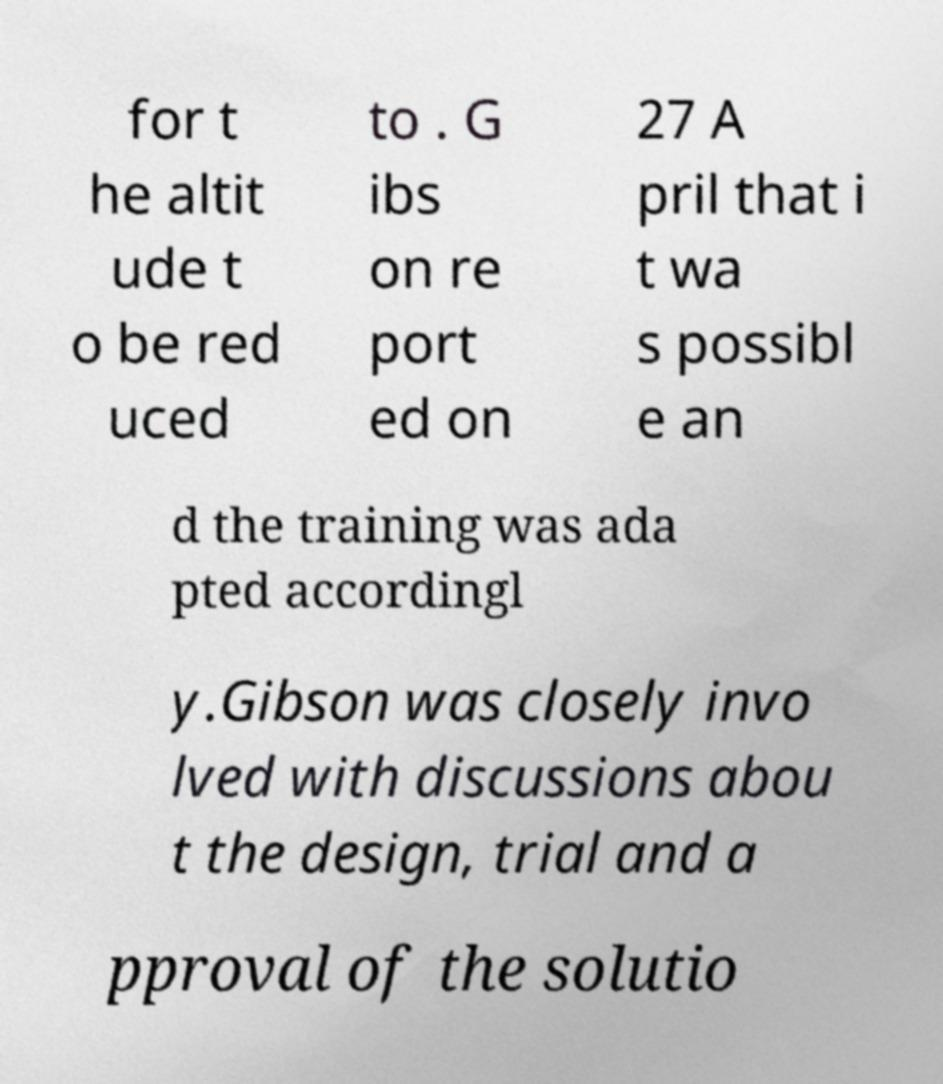Can you read and provide the text displayed in the image?This photo seems to have some interesting text. Can you extract and type it out for me? for t he altit ude t o be red uced to . G ibs on re port ed on 27 A pril that i t wa s possibl e an d the training was ada pted accordingl y.Gibson was closely invo lved with discussions abou t the design, trial and a pproval of the solutio 